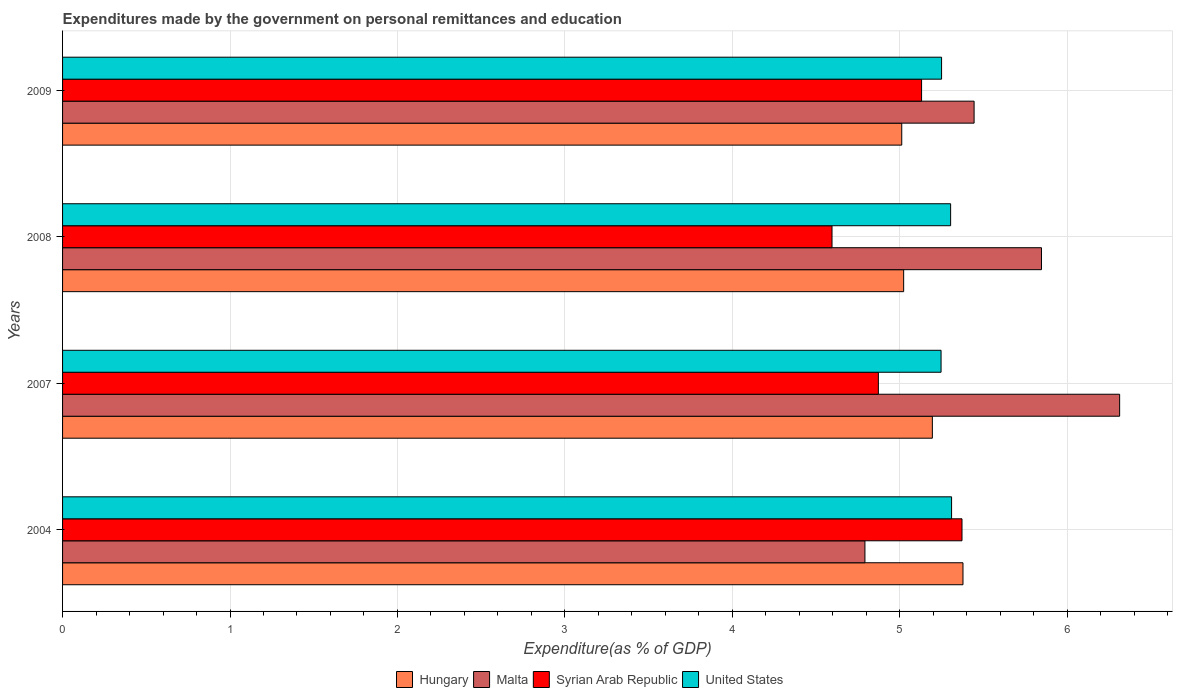How many different coloured bars are there?
Give a very brief answer. 4. Are the number of bars per tick equal to the number of legend labels?
Your response must be concise. Yes. Are the number of bars on each tick of the Y-axis equal?
Ensure brevity in your answer.  Yes. How many bars are there on the 1st tick from the bottom?
Provide a succinct answer. 4. What is the label of the 4th group of bars from the top?
Provide a succinct answer. 2004. In how many cases, is the number of bars for a given year not equal to the number of legend labels?
Provide a short and direct response. 0. What is the expenditures made by the government on personal remittances and education in Syrian Arab Republic in 2004?
Your answer should be compact. 5.37. Across all years, what is the maximum expenditures made by the government on personal remittances and education in Syrian Arab Republic?
Ensure brevity in your answer.  5.37. Across all years, what is the minimum expenditures made by the government on personal remittances and education in Hungary?
Give a very brief answer. 5.01. What is the total expenditures made by the government on personal remittances and education in Malta in the graph?
Ensure brevity in your answer.  22.39. What is the difference between the expenditures made by the government on personal remittances and education in United States in 2004 and that in 2007?
Your answer should be very brief. 0.06. What is the difference between the expenditures made by the government on personal remittances and education in United States in 2009 and the expenditures made by the government on personal remittances and education in Malta in 2008?
Provide a short and direct response. -0.6. What is the average expenditures made by the government on personal remittances and education in United States per year?
Your answer should be very brief. 5.28. In the year 2007, what is the difference between the expenditures made by the government on personal remittances and education in Malta and expenditures made by the government on personal remittances and education in Syrian Arab Republic?
Your response must be concise. 1.44. In how many years, is the expenditures made by the government on personal remittances and education in United States greater than 6.4 %?
Your answer should be very brief. 0. What is the ratio of the expenditures made by the government on personal remittances and education in Hungary in 2008 to that in 2009?
Your answer should be compact. 1. What is the difference between the highest and the second highest expenditures made by the government on personal remittances and education in United States?
Offer a terse response. 0.01. What is the difference between the highest and the lowest expenditures made by the government on personal remittances and education in Hungary?
Your response must be concise. 0.37. Is the sum of the expenditures made by the government on personal remittances and education in Hungary in 2004 and 2007 greater than the maximum expenditures made by the government on personal remittances and education in Syrian Arab Republic across all years?
Your answer should be very brief. Yes. Is it the case that in every year, the sum of the expenditures made by the government on personal remittances and education in United States and expenditures made by the government on personal remittances and education in Syrian Arab Republic is greater than the sum of expenditures made by the government on personal remittances and education in Malta and expenditures made by the government on personal remittances and education in Hungary?
Ensure brevity in your answer.  No. What does the 4th bar from the top in 2009 represents?
Provide a short and direct response. Hungary. What does the 3rd bar from the bottom in 2007 represents?
Your response must be concise. Syrian Arab Republic. Are all the bars in the graph horizontal?
Ensure brevity in your answer.  Yes. How many years are there in the graph?
Your answer should be very brief. 4. What is the difference between two consecutive major ticks on the X-axis?
Your answer should be compact. 1. How are the legend labels stacked?
Offer a very short reply. Horizontal. What is the title of the graph?
Offer a very short reply. Expenditures made by the government on personal remittances and education. Does "Bolivia" appear as one of the legend labels in the graph?
Make the answer very short. No. What is the label or title of the X-axis?
Make the answer very short. Expenditure(as % of GDP). What is the Expenditure(as % of GDP) in Hungary in 2004?
Give a very brief answer. 5.38. What is the Expenditure(as % of GDP) of Malta in 2004?
Keep it short and to the point. 4.79. What is the Expenditure(as % of GDP) of Syrian Arab Republic in 2004?
Provide a short and direct response. 5.37. What is the Expenditure(as % of GDP) in United States in 2004?
Provide a succinct answer. 5.31. What is the Expenditure(as % of GDP) in Hungary in 2007?
Give a very brief answer. 5.19. What is the Expenditure(as % of GDP) of Malta in 2007?
Your answer should be very brief. 6.31. What is the Expenditure(as % of GDP) in Syrian Arab Republic in 2007?
Give a very brief answer. 4.87. What is the Expenditure(as % of GDP) in United States in 2007?
Provide a succinct answer. 5.25. What is the Expenditure(as % of GDP) in Hungary in 2008?
Make the answer very short. 5.02. What is the Expenditure(as % of GDP) in Malta in 2008?
Keep it short and to the point. 5.85. What is the Expenditure(as % of GDP) in Syrian Arab Republic in 2008?
Provide a succinct answer. 4.6. What is the Expenditure(as % of GDP) of United States in 2008?
Offer a terse response. 5.3. What is the Expenditure(as % of GDP) in Hungary in 2009?
Provide a succinct answer. 5.01. What is the Expenditure(as % of GDP) of Malta in 2009?
Keep it short and to the point. 5.44. What is the Expenditure(as % of GDP) of Syrian Arab Republic in 2009?
Ensure brevity in your answer.  5.13. What is the Expenditure(as % of GDP) of United States in 2009?
Give a very brief answer. 5.25. Across all years, what is the maximum Expenditure(as % of GDP) in Hungary?
Your answer should be compact. 5.38. Across all years, what is the maximum Expenditure(as % of GDP) in Malta?
Offer a terse response. 6.31. Across all years, what is the maximum Expenditure(as % of GDP) in Syrian Arab Republic?
Make the answer very short. 5.37. Across all years, what is the maximum Expenditure(as % of GDP) in United States?
Your response must be concise. 5.31. Across all years, what is the minimum Expenditure(as % of GDP) of Hungary?
Provide a short and direct response. 5.01. Across all years, what is the minimum Expenditure(as % of GDP) in Malta?
Keep it short and to the point. 4.79. Across all years, what is the minimum Expenditure(as % of GDP) in Syrian Arab Republic?
Provide a short and direct response. 4.6. Across all years, what is the minimum Expenditure(as % of GDP) in United States?
Give a very brief answer. 5.25. What is the total Expenditure(as % of GDP) in Hungary in the graph?
Provide a succinct answer. 20.61. What is the total Expenditure(as % of GDP) in Malta in the graph?
Your answer should be very brief. 22.39. What is the total Expenditure(as % of GDP) in Syrian Arab Republic in the graph?
Provide a succinct answer. 19.97. What is the total Expenditure(as % of GDP) of United States in the graph?
Provide a succinct answer. 21.11. What is the difference between the Expenditure(as % of GDP) of Hungary in 2004 and that in 2007?
Provide a short and direct response. 0.18. What is the difference between the Expenditure(as % of GDP) in Malta in 2004 and that in 2007?
Give a very brief answer. -1.52. What is the difference between the Expenditure(as % of GDP) of Syrian Arab Republic in 2004 and that in 2007?
Make the answer very short. 0.5. What is the difference between the Expenditure(as % of GDP) of United States in 2004 and that in 2007?
Offer a terse response. 0.06. What is the difference between the Expenditure(as % of GDP) in Hungary in 2004 and that in 2008?
Offer a terse response. 0.35. What is the difference between the Expenditure(as % of GDP) in Malta in 2004 and that in 2008?
Keep it short and to the point. -1.05. What is the difference between the Expenditure(as % of GDP) of Syrian Arab Republic in 2004 and that in 2008?
Ensure brevity in your answer.  0.78. What is the difference between the Expenditure(as % of GDP) of United States in 2004 and that in 2008?
Your answer should be compact. 0.01. What is the difference between the Expenditure(as % of GDP) in Hungary in 2004 and that in 2009?
Offer a terse response. 0.37. What is the difference between the Expenditure(as % of GDP) of Malta in 2004 and that in 2009?
Provide a succinct answer. -0.65. What is the difference between the Expenditure(as % of GDP) in Syrian Arab Republic in 2004 and that in 2009?
Keep it short and to the point. 0.24. What is the difference between the Expenditure(as % of GDP) in United States in 2004 and that in 2009?
Ensure brevity in your answer.  0.06. What is the difference between the Expenditure(as % of GDP) in Hungary in 2007 and that in 2008?
Provide a succinct answer. 0.17. What is the difference between the Expenditure(as % of GDP) of Malta in 2007 and that in 2008?
Provide a short and direct response. 0.47. What is the difference between the Expenditure(as % of GDP) of Syrian Arab Republic in 2007 and that in 2008?
Your answer should be compact. 0.28. What is the difference between the Expenditure(as % of GDP) of United States in 2007 and that in 2008?
Your response must be concise. -0.06. What is the difference between the Expenditure(as % of GDP) in Hungary in 2007 and that in 2009?
Offer a very short reply. 0.18. What is the difference between the Expenditure(as % of GDP) in Malta in 2007 and that in 2009?
Provide a short and direct response. 0.87. What is the difference between the Expenditure(as % of GDP) in Syrian Arab Republic in 2007 and that in 2009?
Offer a very short reply. -0.26. What is the difference between the Expenditure(as % of GDP) of United States in 2007 and that in 2009?
Give a very brief answer. -0. What is the difference between the Expenditure(as % of GDP) in Hungary in 2008 and that in 2009?
Make the answer very short. 0.01. What is the difference between the Expenditure(as % of GDP) in Malta in 2008 and that in 2009?
Ensure brevity in your answer.  0.4. What is the difference between the Expenditure(as % of GDP) of Syrian Arab Republic in 2008 and that in 2009?
Your answer should be very brief. -0.53. What is the difference between the Expenditure(as % of GDP) of United States in 2008 and that in 2009?
Your response must be concise. 0.05. What is the difference between the Expenditure(as % of GDP) in Hungary in 2004 and the Expenditure(as % of GDP) in Malta in 2007?
Your answer should be very brief. -0.94. What is the difference between the Expenditure(as % of GDP) in Hungary in 2004 and the Expenditure(as % of GDP) in Syrian Arab Republic in 2007?
Make the answer very short. 0.51. What is the difference between the Expenditure(as % of GDP) of Hungary in 2004 and the Expenditure(as % of GDP) of United States in 2007?
Provide a short and direct response. 0.13. What is the difference between the Expenditure(as % of GDP) in Malta in 2004 and the Expenditure(as % of GDP) in Syrian Arab Republic in 2007?
Offer a very short reply. -0.08. What is the difference between the Expenditure(as % of GDP) of Malta in 2004 and the Expenditure(as % of GDP) of United States in 2007?
Ensure brevity in your answer.  -0.45. What is the difference between the Expenditure(as % of GDP) of Hungary in 2004 and the Expenditure(as % of GDP) of Malta in 2008?
Offer a very short reply. -0.47. What is the difference between the Expenditure(as % of GDP) of Hungary in 2004 and the Expenditure(as % of GDP) of Syrian Arab Republic in 2008?
Give a very brief answer. 0.78. What is the difference between the Expenditure(as % of GDP) of Hungary in 2004 and the Expenditure(as % of GDP) of United States in 2008?
Give a very brief answer. 0.07. What is the difference between the Expenditure(as % of GDP) in Malta in 2004 and the Expenditure(as % of GDP) in Syrian Arab Republic in 2008?
Ensure brevity in your answer.  0.2. What is the difference between the Expenditure(as % of GDP) in Malta in 2004 and the Expenditure(as % of GDP) in United States in 2008?
Offer a very short reply. -0.51. What is the difference between the Expenditure(as % of GDP) in Syrian Arab Republic in 2004 and the Expenditure(as % of GDP) in United States in 2008?
Make the answer very short. 0.07. What is the difference between the Expenditure(as % of GDP) of Hungary in 2004 and the Expenditure(as % of GDP) of Malta in 2009?
Offer a very short reply. -0.07. What is the difference between the Expenditure(as % of GDP) of Hungary in 2004 and the Expenditure(as % of GDP) of Syrian Arab Republic in 2009?
Your answer should be very brief. 0.25. What is the difference between the Expenditure(as % of GDP) of Hungary in 2004 and the Expenditure(as % of GDP) of United States in 2009?
Ensure brevity in your answer.  0.13. What is the difference between the Expenditure(as % of GDP) of Malta in 2004 and the Expenditure(as % of GDP) of Syrian Arab Republic in 2009?
Provide a succinct answer. -0.34. What is the difference between the Expenditure(as % of GDP) in Malta in 2004 and the Expenditure(as % of GDP) in United States in 2009?
Offer a very short reply. -0.46. What is the difference between the Expenditure(as % of GDP) in Syrian Arab Republic in 2004 and the Expenditure(as % of GDP) in United States in 2009?
Your answer should be compact. 0.12. What is the difference between the Expenditure(as % of GDP) in Hungary in 2007 and the Expenditure(as % of GDP) in Malta in 2008?
Give a very brief answer. -0.65. What is the difference between the Expenditure(as % of GDP) in Hungary in 2007 and the Expenditure(as % of GDP) in Syrian Arab Republic in 2008?
Provide a succinct answer. 0.6. What is the difference between the Expenditure(as % of GDP) of Hungary in 2007 and the Expenditure(as % of GDP) of United States in 2008?
Your answer should be very brief. -0.11. What is the difference between the Expenditure(as % of GDP) of Malta in 2007 and the Expenditure(as % of GDP) of Syrian Arab Republic in 2008?
Ensure brevity in your answer.  1.72. What is the difference between the Expenditure(as % of GDP) of Malta in 2007 and the Expenditure(as % of GDP) of United States in 2008?
Provide a succinct answer. 1.01. What is the difference between the Expenditure(as % of GDP) of Syrian Arab Republic in 2007 and the Expenditure(as % of GDP) of United States in 2008?
Provide a succinct answer. -0.43. What is the difference between the Expenditure(as % of GDP) in Hungary in 2007 and the Expenditure(as % of GDP) in Malta in 2009?
Your answer should be very brief. -0.25. What is the difference between the Expenditure(as % of GDP) in Hungary in 2007 and the Expenditure(as % of GDP) in Syrian Arab Republic in 2009?
Make the answer very short. 0.06. What is the difference between the Expenditure(as % of GDP) in Hungary in 2007 and the Expenditure(as % of GDP) in United States in 2009?
Offer a very short reply. -0.06. What is the difference between the Expenditure(as % of GDP) in Malta in 2007 and the Expenditure(as % of GDP) in Syrian Arab Republic in 2009?
Your response must be concise. 1.18. What is the difference between the Expenditure(as % of GDP) of Malta in 2007 and the Expenditure(as % of GDP) of United States in 2009?
Your answer should be very brief. 1.06. What is the difference between the Expenditure(as % of GDP) in Syrian Arab Republic in 2007 and the Expenditure(as % of GDP) in United States in 2009?
Offer a very short reply. -0.38. What is the difference between the Expenditure(as % of GDP) of Hungary in 2008 and the Expenditure(as % of GDP) of Malta in 2009?
Your answer should be very brief. -0.42. What is the difference between the Expenditure(as % of GDP) in Hungary in 2008 and the Expenditure(as % of GDP) in Syrian Arab Republic in 2009?
Provide a succinct answer. -0.11. What is the difference between the Expenditure(as % of GDP) in Hungary in 2008 and the Expenditure(as % of GDP) in United States in 2009?
Make the answer very short. -0.23. What is the difference between the Expenditure(as % of GDP) in Malta in 2008 and the Expenditure(as % of GDP) in Syrian Arab Republic in 2009?
Keep it short and to the point. 0.72. What is the difference between the Expenditure(as % of GDP) in Malta in 2008 and the Expenditure(as % of GDP) in United States in 2009?
Your answer should be very brief. 0.6. What is the difference between the Expenditure(as % of GDP) in Syrian Arab Republic in 2008 and the Expenditure(as % of GDP) in United States in 2009?
Provide a short and direct response. -0.65. What is the average Expenditure(as % of GDP) in Hungary per year?
Make the answer very short. 5.15. What is the average Expenditure(as % of GDP) in Malta per year?
Your answer should be very brief. 5.6. What is the average Expenditure(as % of GDP) of Syrian Arab Republic per year?
Offer a terse response. 4.99. What is the average Expenditure(as % of GDP) of United States per year?
Provide a succinct answer. 5.28. In the year 2004, what is the difference between the Expenditure(as % of GDP) of Hungary and Expenditure(as % of GDP) of Malta?
Offer a terse response. 0.59. In the year 2004, what is the difference between the Expenditure(as % of GDP) in Hungary and Expenditure(as % of GDP) in Syrian Arab Republic?
Your response must be concise. 0.01. In the year 2004, what is the difference between the Expenditure(as % of GDP) in Hungary and Expenditure(as % of GDP) in United States?
Ensure brevity in your answer.  0.07. In the year 2004, what is the difference between the Expenditure(as % of GDP) in Malta and Expenditure(as % of GDP) in Syrian Arab Republic?
Your answer should be compact. -0.58. In the year 2004, what is the difference between the Expenditure(as % of GDP) of Malta and Expenditure(as % of GDP) of United States?
Make the answer very short. -0.52. In the year 2004, what is the difference between the Expenditure(as % of GDP) of Syrian Arab Republic and Expenditure(as % of GDP) of United States?
Keep it short and to the point. 0.06. In the year 2007, what is the difference between the Expenditure(as % of GDP) of Hungary and Expenditure(as % of GDP) of Malta?
Your answer should be very brief. -1.12. In the year 2007, what is the difference between the Expenditure(as % of GDP) in Hungary and Expenditure(as % of GDP) in Syrian Arab Republic?
Ensure brevity in your answer.  0.32. In the year 2007, what is the difference between the Expenditure(as % of GDP) in Hungary and Expenditure(as % of GDP) in United States?
Your answer should be compact. -0.05. In the year 2007, what is the difference between the Expenditure(as % of GDP) of Malta and Expenditure(as % of GDP) of Syrian Arab Republic?
Provide a short and direct response. 1.44. In the year 2007, what is the difference between the Expenditure(as % of GDP) in Malta and Expenditure(as % of GDP) in United States?
Make the answer very short. 1.07. In the year 2007, what is the difference between the Expenditure(as % of GDP) in Syrian Arab Republic and Expenditure(as % of GDP) in United States?
Your answer should be compact. -0.37. In the year 2008, what is the difference between the Expenditure(as % of GDP) of Hungary and Expenditure(as % of GDP) of Malta?
Give a very brief answer. -0.82. In the year 2008, what is the difference between the Expenditure(as % of GDP) of Hungary and Expenditure(as % of GDP) of Syrian Arab Republic?
Offer a very short reply. 0.43. In the year 2008, what is the difference between the Expenditure(as % of GDP) in Hungary and Expenditure(as % of GDP) in United States?
Your answer should be very brief. -0.28. In the year 2008, what is the difference between the Expenditure(as % of GDP) of Malta and Expenditure(as % of GDP) of Syrian Arab Republic?
Offer a terse response. 1.25. In the year 2008, what is the difference between the Expenditure(as % of GDP) in Malta and Expenditure(as % of GDP) in United States?
Your answer should be compact. 0.54. In the year 2008, what is the difference between the Expenditure(as % of GDP) in Syrian Arab Republic and Expenditure(as % of GDP) in United States?
Keep it short and to the point. -0.71. In the year 2009, what is the difference between the Expenditure(as % of GDP) of Hungary and Expenditure(as % of GDP) of Malta?
Offer a very short reply. -0.43. In the year 2009, what is the difference between the Expenditure(as % of GDP) of Hungary and Expenditure(as % of GDP) of Syrian Arab Republic?
Provide a short and direct response. -0.12. In the year 2009, what is the difference between the Expenditure(as % of GDP) in Hungary and Expenditure(as % of GDP) in United States?
Provide a short and direct response. -0.24. In the year 2009, what is the difference between the Expenditure(as % of GDP) of Malta and Expenditure(as % of GDP) of Syrian Arab Republic?
Provide a succinct answer. 0.31. In the year 2009, what is the difference between the Expenditure(as % of GDP) of Malta and Expenditure(as % of GDP) of United States?
Ensure brevity in your answer.  0.19. In the year 2009, what is the difference between the Expenditure(as % of GDP) in Syrian Arab Republic and Expenditure(as % of GDP) in United States?
Your answer should be very brief. -0.12. What is the ratio of the Expenditure(as % of GDP) of Hungary in 2004 to that in 2007?
Give a very brief answer. 1.04. What is the ratio of the Expenditure(as % of GDP) of Malta in 2004 to that in 2007?
Your answer should be very brief. 0.76. What is the ratio of the Expenditure(as % of GDP) of Syrian Arab Republic in 2004 to that in 2007?
Your answer should be very brief. 1.1. What is the ratio of the Expenditure(as % of GDP) in United States in 2004 to that in 2007?
Offer a very short reply. 1.01. What is the ratio of the Expenditure(as % of GDP) in Hungary in 2004 to that in 2008?
Ensure brevity in your answer.  1.07. What is the ratio of the Expenditure(as % of GDP) in Malta in 2004 to that in 2008?
Your response must be concise. 0.82. What is the ratio of the Expenditure(as % of GDP) of Syrian Arab Republic in 2004 to that in 2008?
Your answer should be compact. 1.17. What is the ratio of the Expenditure(as % of GDP) of Hungary in 2004 to that in 2009?
Offer a very short reply. 1.07. What is the ratio of the Expenditure(as % of GDP) in Malta in 2004 to that in 2009?
Offer a terse response. 0.88. What is the ratio of the Expenditure(as % of GDP) of Syrian Arab Republic in 2004 to that in 2009?
Your answer should be very brief. 1.05. What is the ratio of the Expenditure(as % of GDP) in United States in 2004 to that in 2009?
Your response must be concise. 1.01. What is the ratio of the Expenditure(as % of GDP) in Hungary in 2007 to that in 2008?
Your answer should be very brief. 1.03. What is the ratio of the Expenditure(as % of GDP) of Malta in 2007 to that in 2008?
Provide a succinct answer. 1.08. What is the ratio of the Expenditure(as % of GDP) of Syrian Arab Republic in 2007 to that in 2008?
Your answer should be compact. 1.06. What is the ratio of the Expenditure(as % of GDP) of United States in 2007 to that in 2008?
Offer a terse response. 0.99. What is the ratio of the Expenditure(as % of GDP) in Hungary in 2007 to that in 2009?
Keep it short and to the point. 1.04. What is the ratio of the Expenditure(as % of GDP) of Malta in 2007 to that in 2009?
Provide a succinct answer. 1.16. What is the ratio of the Expenditure(as % of GDP) in Syrian Arab Republic in 2007 to that in 2009?
Your response must be concise. 0.95. What is the ratio of the Expenditure(as % of GDP) of Malta in 2008 to that in 2009?
Your response must be concise. 1.07. What is the ratio of the Expenditure(as % of GDP) in Syrian Arab Republic in 2008 to that in 2009?
Make the answer very short. 0.9. What is the ratio of the Expenditure(as % of GDP) in United States in 2008 to that in 2009?
Your response must be concise. 1.01. What is the difference between the highest and the second highest Expenditure(as % of GDP) of Hungary?
Provide a short and direct response. 0.18. What is the difference between the highest and the second highest Expenditure(as % of GDP) in Malta?
Your answer should be compact. 0.47. What is the difference between the highest and the second highest Expenditure(as % of GDP) in Syrian Arab Republic?
Offer a terse response. 0.24. What is the difference between the highest and the second highest Expenditure(as % of GDP) in United States?
Your response must be concise. 0.01. What is the difference between the highest and the lowest Expenditure(as % of GDP) of Hungary?
Give a very brief answer. 0.37. What is the difference between the highest and the lowest Expenditure(as % of GDP) in Malta?
Provide a succinct answer. 1.52. What is the difference between the highest and the lowest Expenditure(as % of GDP) of Syrian Arab Republic?
Your answer should be compact. 0.78. What is the difference between the highest and the lowest Expenditure(as % of GDP) in United States?
Ensure brevity in your answer.  0.06. 